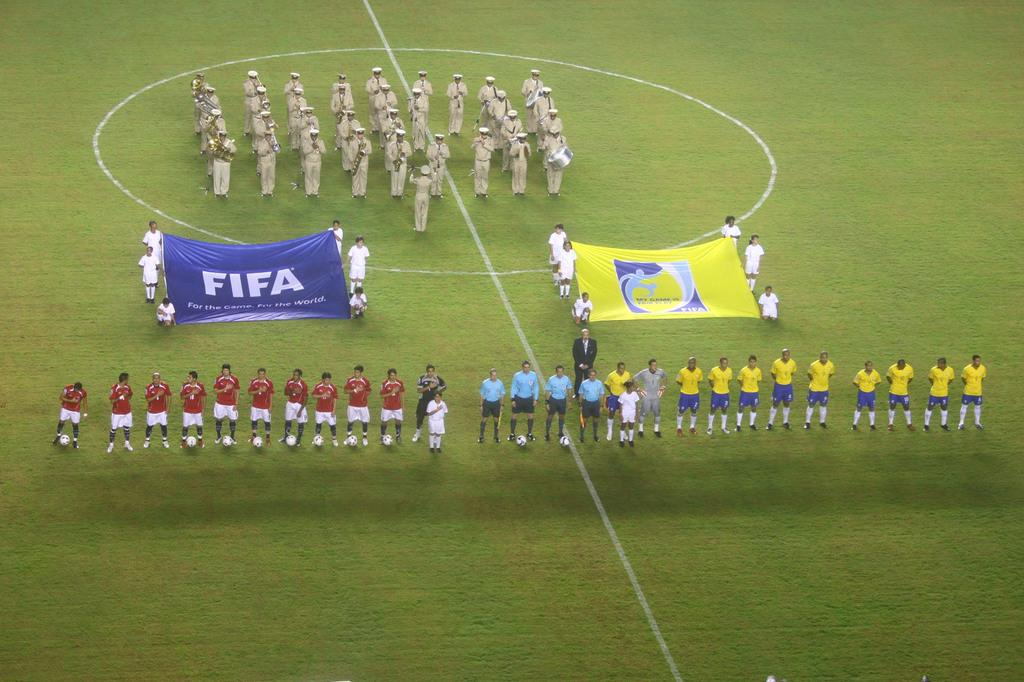<image>
Give a short and clear explanation of the subsequent image. Soccer players hold up a banner that says FIFA. 